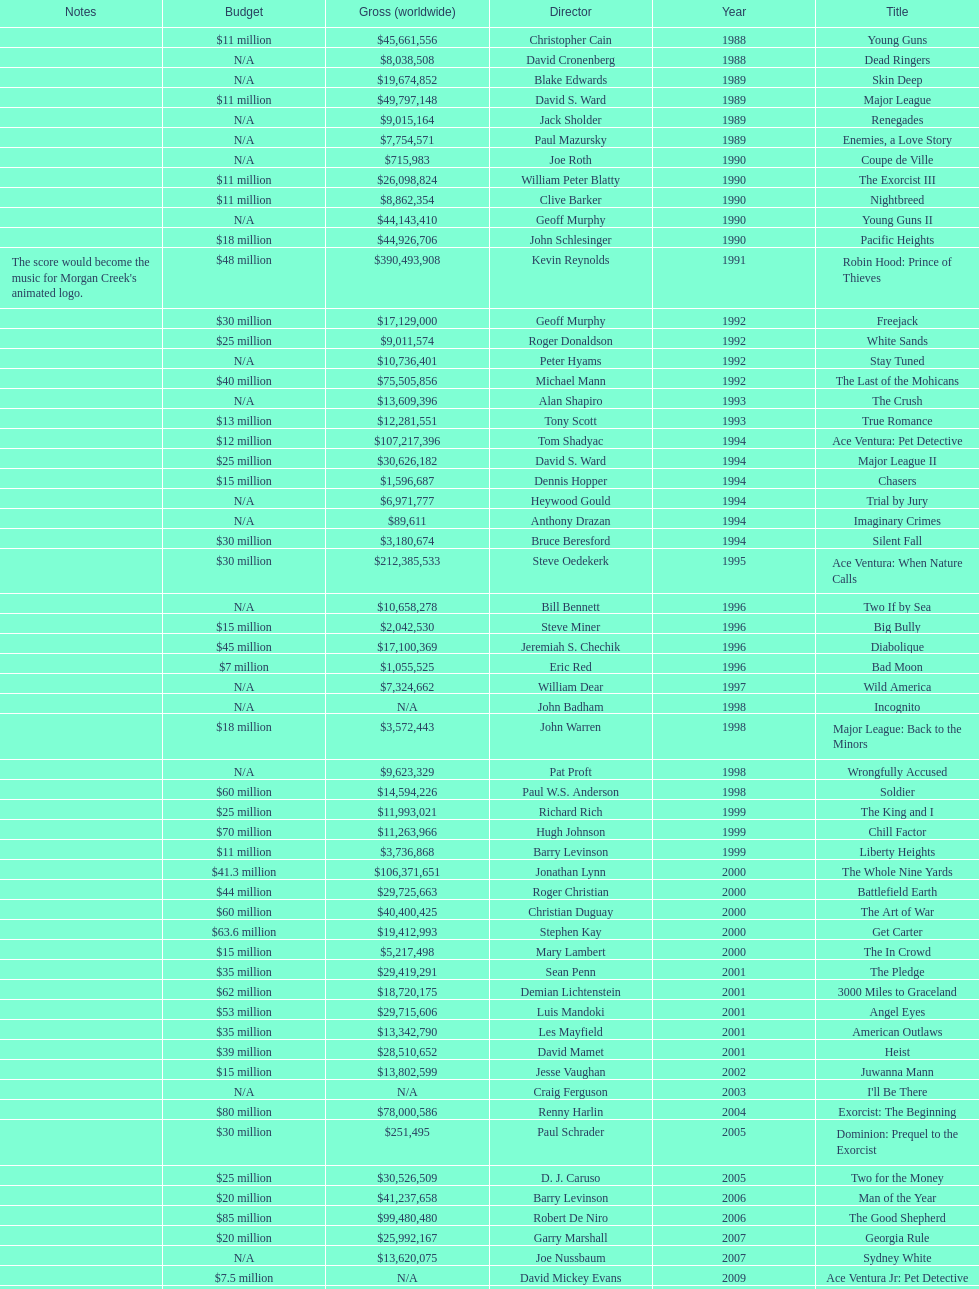What movie came out after bad moon? Wild America. 